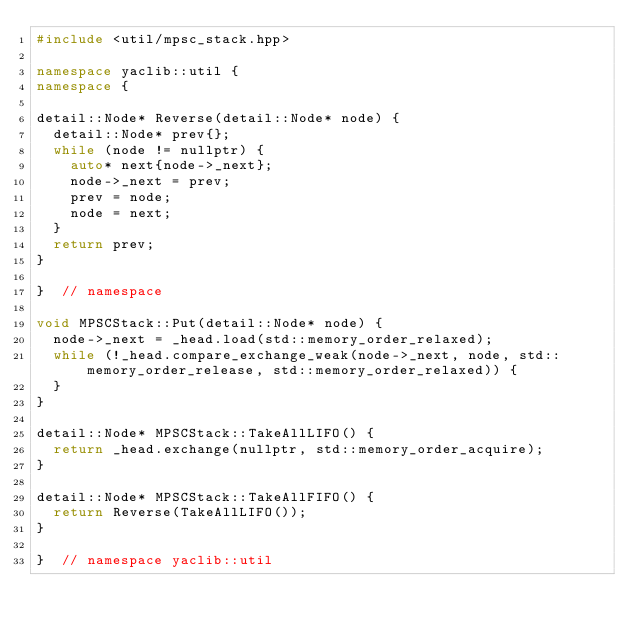Convert code to text. <code><loc_0><loc_0><loc_500><loc_500><_C++_>#include <util/mpsc_stack.hpp>

namespace yaclib::util {
namespace {

detail::Node* Reverse(detail::Node* node) {
  detail::Node* prev{};
  while (node != nullptr) {
    auto* next{node->_next};
    node->_next = prev;
    prev = node;
    node = next;
  }
  return prev;
}

}  // namespace

void MPSCStack::Put(detail::Node* node) {
  node->_next = _head.load(std::memory_order_relaxed);
  while (!_head.compare_exchange_weak(node->_next, node, std::memory_order_release, std::memory_order_relaxed)) {
  }
}

detail::Node* MPSCStack::TakeAllLIFO() {
  return _head.exchange(nullptr, std::memory_order_acquire);
}

detail::Node* MPSCStack::TakeAllFIFO() {
  return Reverse(TakeAllLIFO());
}

}  // namespace yaclib::util
</code> 